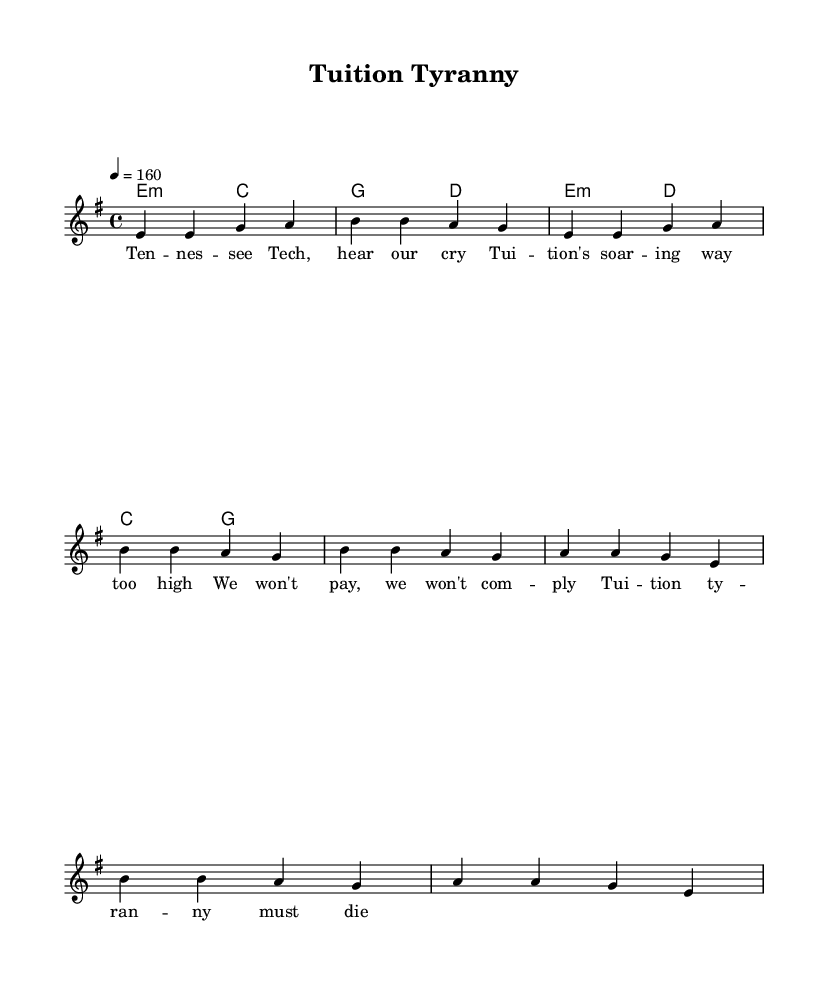What is the key signature of this music? The key signature is indicated as E minor, which includes one sharp (F#).
Answer: E minor What is the time signature of this music? The time signature is indicated at the beginning of the score as 4/4, meaning there are four beats per measure.
Answer: 4/4 What is the tempo marking of the piece? The tempo marking is 4 equals 160, referring to a quarter note equaling 160 beats per minute.
Answer: 160 How many measures are in the verse section? The verse consists of two phrases with four measures each, totaling eight measures.
Answer: 8 What are the first two lyrics of the song? The lyrics for the verse start with "Tennessee Tech, hear our cry".
Answer: Tennessee Tech What type of song is this, based on its theme? The song addresses protests against rising tuition costs, making it a protest anthem typical in punk music.
Answer: Protest anthem What is the primary message conveyed in the chorus? The primary message in the chorus is a refusal to comply with tuition increases, highlighting rebellion against "tuition tyranny".
Answer: Refusal to comply 